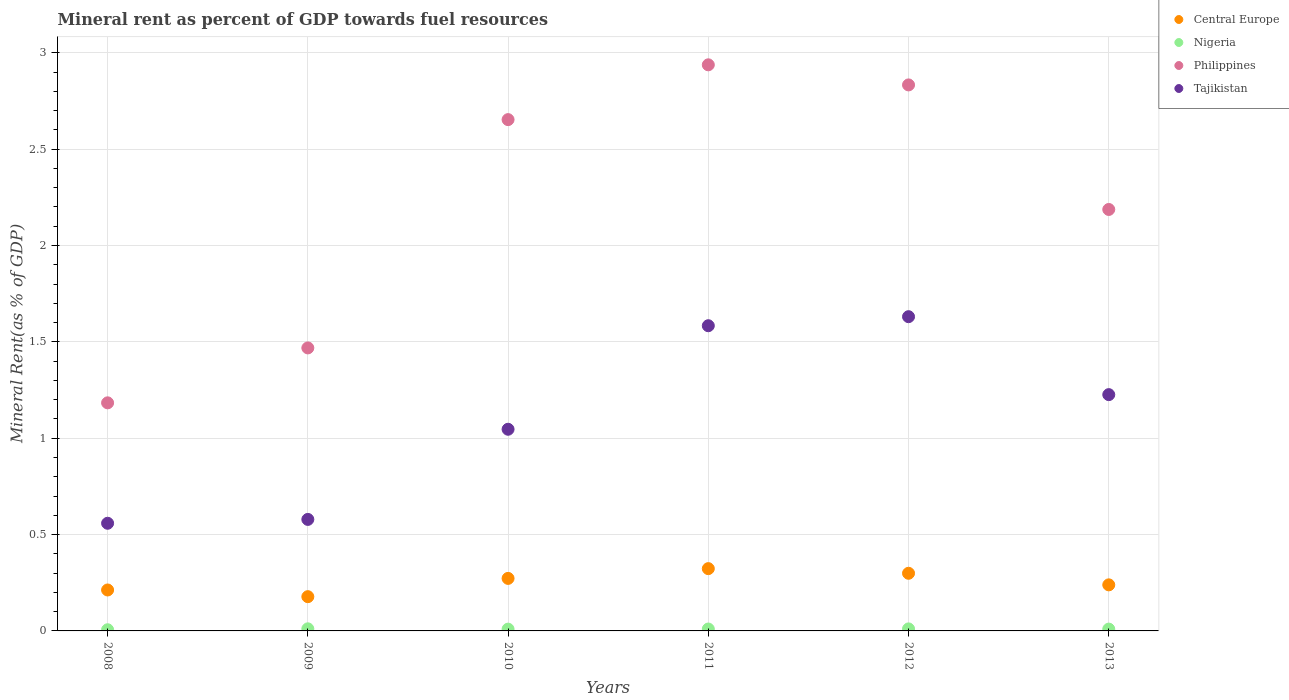How many different coloured dotlines are there?
Provide a short and direct response. 4. Is the number of dotlines equal to the number of legend labels?
Your response must be concise. Yes. What is the mineral rent in Nigeria in 2011?
Give a very brief answer. 0.01. Across all years, what is the maximum mineral rent in Tajikistan?
Provide a succinct answer. 1.63. Across all years, what is the minimum mineral rent in Philippines?
Make the answer very short. 1.18. What is the total mineral rent in Philippines in the graph?
Give a very brief answer. 13.26. What is the difference between the mineral rent in Central Europe in 2009 and that in 2012?
Provide a short and direct response. -0.12. What is the difference between the mineral rent in Central Europe in 2011 and the mineral rent in Tajikistan in 2010?
Your answer should be very brief. -0.72. What is the average mineral rent in Tajikistan per year?
Your response must be concise. 1.1. In the year 2010, what is the difference between the mineral rent in Nigeria and mineral rent in Tajikistan?
Make the answer very short. -1.04. In how many years, is the mineral rent in Philippines greater than 1.9 %?
Make the answer very short. 4. What is the ratio of the mineral rent in Philippines in 2009 to that in 2013?
Keep it short and to the point. 0.67. Is the mineral rent in Philippines in 2009 less than that in 2012?
Offer a terse response. Yes. What is the difference between the highest and the second highest mineral rent in Tajikistan?
Ensure brevity in your answer.  0.05. What is the difference between the highest and the lowest mineral rent in Nigeria?
Keep it short and to the point. 0. In how many years, is the mineral rent in Philippines greater than the average mineral rent in Philippines taken over all years?
Provide a succinct answer. 3. Is it the case that in every year, the sum of the mineral rent in Tajikistan and mineral rent in Philippines  is greater than the mineral rent in Central Europe?
Give a very brief answer. Yes. Does the mineral rent in Philippines monotonically increase over the years?
Provide a succinct answer. No. Is the mineral rent in Nigeria strictly greater than the mineral rent in Central Europe over the years?
Provide a succinct answer. No. How many dotlines are there?
Make the answer very short. 4. What is the difference between two consecutive major ticks on the Y-axis?
Keep it short and to the point. 0.5. Does the graph contain any zero values?
Provide a succinct answer. No. Does the graph contain grids?
Provide a succinct answer. Yes. How are the legend labels stacked?
Ensure brevity in your answer.  Vertical. What is the title of the graph?
Make the answer very short. Mineral rent as percent of GDP towards fuel resources. Does "Low & middle income" appear as one of the legend labels in the graph?
Offer a very short reply. No. What is the label or title of the X-axis?
Ensure brevity in your answer.  Years. What is the label or title of the Y-axis?
Offer a terse response. Mineral Rent(as % of GDP). What is the Mineral Rent(as % of GDP) in Central Europe in 2008?
Offer a terse response. 0.21. What is the Mineral Rent(as % of GDP) in Nigeria in 2008?
Ensure brevity in your answer.  0.01. What is the Mineral Rent(as % of GDP) of Philippines in 2008?
Your answer should be compact. 1.18. What is the Mineral Rent(as % of GDP) in Tajikistan in 2008?
Make the answer very short. 0.56. What is the Mineral Rent(as % of GDP) of Central Europe in 2009?
Provide a short and direct response. 0.18. What is the Mineral Rent(as % of GDP) in Nigeria in 2009?
Your answer should be very brief. 0.01. What is the Mineral Rent(as % of GDP) in Philippines in 2009?
Your answer should be compact. 1.47. What is the Mineral Rent(as % of GDP) in Tajikistan in 2009?
Your answer should be compact. 0.58. What is the Mineral Rent(as % of GDP) of Central Europe in 2010?
Offer a terse response. 0.27. What is the Mineral Rent(as % of GDP) of Nigeria in 2010?
Provide a succinct answer. 0.01. What is the Mineral Rent(as % of GDP) of Philippines in 2010?
Give a very brief answer. 2.65. What is the Mineral Rent(as % of GDP) in Tajikistan in 2010?
Your response must be concise. 1.05. What is the Mineral Rent(as % of GDP) in Central Europe in 2011?
Offer a terse response. 0.32. What is the Mineral Rent(as % of GDP) of Nigeria in 2011?
Your response must be concise. 0.01. What is the Mineral Rent(as % of GDP) of Philippines in 2011?
Provide a short and direct response. 2.94. What is the Mineral Rent(as % of GDP) in Tajikistan in 2011?
Your answer should be very brief. 1.58. What is the Mineral Rent(as % of GDP) in Central Europe in 2012?
Keep it short and to the point. 0.3. What is the Mineral Rent(as % of GDP) of Nigeria in 2012?
Provide a succinct answer. 0.01. What is the Mineral Rent(as % of GDP) in Philippines in 2012?
Offer a very short reply. 2.83. What is the Mineral Rent(as % of GDP) in Tajikistan in 2012?
Your answer should be compact. 1.63. What is the Mineral Rent(as % of GDP) of Central Europe in 2013?
Provide a short and direct response. 0.24. What is the Mineral Rent(as % of GDP) of Nigeria in 2013?
Give a very brief answer. 0.01. What is the Mineral Rent(as % of GDP) in Philippines in 2013?
Offer a terse response. 2.19. What is the Mineral Rent(as % of GDP) of Tajikistan in 2013?
Ensure brevity in your answer.  1.23. Across all years, what is the maximum Mineral Rent(as % of GDP) in Central Europe?
Your answer should be compact. 0.32. Across all years, what is the maximum Mineral Rent(as % of GDP) in Nigeria?
Keep it short and to the point. 0.01. Across all years, what is the maximum Mineral Rent(as % of GDP) in Philippines?
Your answer should be very brief. 2.94. Across all years, what is the maximum Mineral Rent(as % of GDP) of Tajikistan?
Make the answer very short. 1.63. Across all years, what is the minimum Mineral Rent(as % of GDP) of Central Europe?
Ensure brevity in your answer.  0.18. Across all years, what is the minimum Mineral Rent(as % of GDP) in Nigeria?
Your answer should be very brief. 0.01. Across all years, what is the minimum Mineral Rent(as % of GDP) in Philippines?
Offer a very short reply. 1.18. Across all years, what is the minimum Mineral Rent(as % of GDP) of Tajikistan?
Provide a short and direct response. 0.56. What is the total Mineral Rent(as % of GDP) of Central Europe in the graph?
Offer a terse response. 1.52. What is the total Mineral Rent(as % of GDP) in Nigeria in the graph?
Provide a succinct answer. 0.06. What is the total Mineral Rent(as % of GDP) of Philippines in the graph?
Your answer should be very brief. 13.26. What is the total Mineral Rent(as % of GDP) of Tajikistan in the graph?
Provide a succinct answer. 6.62. What is the difference between the Mineral Rent(as % of GDP) of Central Europe in 2008 and that in 2009?
Provide a succinct answer. 0.03. What is the difference between the Mineral Rent(as % of GDP) in Nigeria in 2008 and that in 2009?
Ensure brevity in your answer.  -0. What is the difference between the Mineral Rent(as % of GDP) in Philippines in 2008 and that in 2009?
Your answer should be very brief. -0.28. What is the difference between the Mineral Rent(as % of GDP) of Tajikistan in 2008 and that in 2009?
Make the answer very short. -0.02. What is the difference between the Mineral Rent(as % of GDP) of Central Europe in 2008 and that in 2010?
Ensure brevity in your answer.  -0.06. What is the difference between the Mineral Rent(as % of GDP) in Nigeria in 2008 and that in 2010?
Make the answer very short. -0. What is the difference between the Mineral Rent(as % of GDP) in Philippines in 2008 and that in 2010?
Ensure brevity in your answer.  -1.47. What is the difference between the Mineral Rent(as % of GDP) in Tajikistan in 2008 and that in 2010?
Your answer should be compact. -0.49. What is the difference between the Mineral Rent(as % of GDP) in Central Europe in 2008 and that in 2011?
Your answer should be very brief. -0.11. What is the difference between the Mineral Rent(as % of GDP) in Nigeria in 2008 and that in 2011?
Your answer should be compact. -0. What is the difference between the Mineral Rent(as % of GDP) in Philippines in 2008 and that in 2011?
Keep it short and to the point. -1.75. What is the difference between the Mineral Rent(as % of GDP) of Tajikistan in 2008 and that in 2011?
Your response must be concise. -1.03. What is the difference between the Mineral Rent(as % of GDP) in Central Europe in 2008 and that in 2012?
Provide a short and direct response. -0.09. What is the difference between the Mineral Rent(as % of GDP) of Nigeria in 2008 and that in 2012?
Offer a very short reply. -0. What is the difference between the Mineral Rent(as % of GDP) in Philippines in 2008 and that in 2012?
Provide a succinct answer. -1.65. What is the difference between the Mineral Rent(as % of GDP) in Tajikistan in 2008 and that in 2012?
Provide a succinct answer. -1.07. What is the difference between the Mineral Rent(as % of GDP) in Central Europe in 2008 and that in 2013?
Provide a succinct answer. -0.03. What is the difference between the Mineral Rent(as % of GDP) in Nigeria in 2008 and that in 2013?
Your answer should be compact. -0. What is the difference between the Mineral Rent(as % of GDP) in Philippines in 2008 and that in 2013?
Offer a very short reply. -1. What is the difference between the Mineral Rent(as % of GDP) of Tajikistan in 2008 and that in 2013?
Your answer should be very brief. -0.67. What is the difference between the Mineral Rent(as % of GDP) of Central Europe in 2009 and that in 2010?
Ensure brevity in your answer.  -0.09. What is the difference between the Mineral Rent(as % of GDP) of Nigeria in 2009 and that in 2010?
Ensure brevity in your answer.  0. What is the difference between the Mineral Rent(as % of GDP) in Philippines in 2009 and that in 2010?
Provide a succinct answer. -1.18. What is the difference between the Mineral Rent(as % of GDP) of Tajikistan in 2009 and that in 2010?
Provide a short and direct response. -0.47. What is the difference between the Mineral Rent(as % of GDP) of Central Europe in 2009 and that in 2011?
Keep it short and to the point. -0.15. What is the difference between the Mineral Rent(as % of GDP) in Philippines in 2009 and that in 2011?
Your response must be concise. -1.47. What is the difference between the Mineral Rent(as % of GDP) of Tajikistan in 2009 and that in 2011?
Offer a very short reply. -1.01. What is the difference between the Mineral Rent(as % of GDP) of Central Europe in 2009 and that in 2012?
Give a very brief answer. -0.12. What is the difference between the Mineral Rent(as % of GDP) in Philippines in 2009 and that in 2012?
Offer a terse response. -1.36. What is the difference between the Mineral Rent(as % of GDP) of Tajikistan in 2009 and that in 2012?
Give a very brief answer. -1.05. What is the difference between the Mineral Rent(as % of GDP) in Central Europe in 2009 and that in 2013?
Offer a terse response. -0.06. What is the difference between the Mineral Rent(as % of GDP) in Nigeria in 2009 and that in 2013?
Your answer should be compact. 0. What is the difference between the Mineral Rent(as % of GDP) of Philippines in 2009 and that in 2013?
Your answer should be compact. -0.72. What is the difference between the Mineral Rent(as % of GDP) in Tajikistan in 2009 and that in 2013?
Offer a terse response. -0.65. What is the difference between the Mineral Rent(as % of GDP) in Central Europe in 2010 and that in 2011?
Your answer should be very brief. -0.05. What is the difference between the Mineral Rent(as % of GDP) in Nigeria in 2010 and that in 2011?
Keep it short and to the point. -0. What is the difference between the Mineral Rent(as % of GDP) of Philippines in 2010 and that in 2011?
Offer a very short reply. -0.28. What is the difference between the Mineral Rent(as % of GDP) of Tajikistan in 2010 and that in 2011?
Provide a succinct answer. -0.54. What is the difference between the Mineral Rent(as % of GDP) of Central Europe in 2010 and that in 2012?
Offer a terse response. -0.03. What is the difference between the Mineral Rent(as % of GDP) in Nigeria in 2010 and that in 2012?
Your response must be concise. -0. What is the difference between the Mineral Rent(as % of GDP) in Philippines in 2010 and that in 2012?
Your response must be concise. -0.18. What is the difference between the Mineral Rent(as % of GDP) of Tajikistan in 2010 and that in 2012?
Your answer should be compact. -0.58. What is the difference between the Mineral Rent(as % of GDP) of Central Europe in 2010 and that in 2013?
Ensure brevity in your answer.  0.03. What is the difference between the Mineral Rent(as % of GDP) of Nigeria in 2010 and that in 2013?
Give a very brief answer. -0. What is the difference between the Mineral Rent(as % of GDP) of Philippines in 2010 and that in 2013?
Your answer should be very brief. 0.47. What is the difference between the Mineral Rent(as % of GDP) of Tajikistan in 2010 and that in 2013?
Your answer should be very brief. -0.18. What is the difference between the Mineral Rent(as % of GDP) of Central Europe in 2011 and that in 2012?
Keep it short and to the point. 0.02. What is the difference between the Mineral Rent(as % of GDP) of Nigeria in 2011 and that in 2012?
Provide a short and direct response. -0. What is the difference between the Mineral Rent(as % of GDP) of Philippines in 2011 and that in 2012?
Your answer should be compact. 0.1. What is the difference between the Mineral Rent(as % of GDP) of Tajikistan in 2011 and that in 2012?
Keep it short and to the point. -0.05. What is the difference between the Mineral Rent(as % of GDP) in Central Europe in 2011 and that in 2013?
Your response must be concise. 0.08. What is the difference between the Mineral Rent(as % of GDP) of Philippines in 2011 and that in 2013?
Provide a short and direct response. 0.75. What is the difference between the Mineral Rent(as % of GDP) of Tajikistan in 2011 and that in 2013?
Ensure brevity in your answer.  0.36. What is the difference between the Mineral Rent(as % of GDP) in Central Europe in 2012 and that in 2013?
Provide a succinct answer. 0.06. What is the difference between the Mineral Rent(as % of GDP) in Nigeria in 2012 and that in 2013?
Offer a terse response. 0. What is the difference between the Mineral Rent(as % of GDP) in Philippines in 2012 and that in 2013?
Your response must be concise. 0.65. What is the difference between the Mineral Rent(as % of GDP) in Tajikistan in 2012 and that in 2013?
Your answer should be compact. 0.4. What is the difference between the Mineral Rent(as % of GDP) of Central Europe in 2008 and the Mineral Rent(as % of GDP) of Nigeria in 2009?
Your response must be concise. 0.2. What is the difference between the Mineral Rent(as % of GDP) in Central Europe in 2008 and the Mineral Rent(as % of GDP) in Philippines in 2009?
Your response must be concise. -1.26. What is the difference between the Mineral Rent(as % of GDP) in Central Europe in 2008 and the Mineral Rent(as % of GDP) in Tajikistan in 2009?
Offer a terse response. -0.37. What is the difference between the Mineral Rent(as % of GDP) of Nigeria in 2008 and the Mineral Rent(as % of GDP) of Philippines in 2009?
Your response must be concise. -1.46. What is the difference between the Mineral Rent(as % of GDP) of Nigeria in 2008 and the Mineral Rent(as % of GDP) of Tajikistan in 2009?
Provide a short and direct response. -0.57. What is the difference between the Mineral Rent(as % of GDP) of Philippines in 2008 and the Mineral Rent(as % of GDP) of Tajikistan in 2009?
Ensure brevity in your answer.  0.6. What is the difference between the Mineral Rent(as % of GDP) in Central Europe in 2008 and the Mineral Rent(as % of GDP) in Nigeria in 2010?
Your response must be concise. 0.2. What is the difference between the Mineral Rent(as % of GDP) of Central Europe in 2008 and the Mineral Rent(as % of GDP) of Philippines in 2010?
Give a very brief answer. -2.44. What is the difference between the Mineral Rent(as % of GDP) of Central Europe in 2008 and the Mineral Rent(as % of GDP) of Tajikistan in 2010?
Your answer should be very brief. -0.83. What is the difference between the Mineral Rent(as % of GDP) of Nigeria in 2008 and the Mineral Rent(as % of GDP) of Philippines in 2010?
Provide a succinct answer. -2.65. What is the difference between the Mineral Rent(as % of GDP) in Nigeria in 2008 and the Mineral Rent(as % of GDP) in Tajikistan in 2010?
Offer a very short reply. -1.04. What is the difference between the Mineral Rent(as % of GDP) in Philippines in 2008 and the Mineral Rent(as % of GDP) in Tajikistan in 2010?
Provide a succinct answer. 0.14. What is the difference between the Mineral Rent(as % of GDP) in Central Europe in 2008 and the Mineral Rent(as % of GDP) in Nigeria in 2011?
Provide a succinct answer. 0.2. What is the difference between the Mineral Rent(as % of GDP) of Central Europe in 2008 and the Mineral Rent(as % of GDP) of Philippines in 2011?
Your answer should be very brief. -2.73. What is the difference between the Mineral Rent(as % of GDP) in Central Europe in 2008 and the Mineral Rent(as % of GDP) in Tajikistan in 2011?
Offer a terse response. -1.37. What is the difference between the Mineral Rent(as % of GDP) in Nigeria in 2008 and the Mineral Rent(as % of GDP) in Philippines in 2011?
Keep it short and to the point. -2.93. What is the difference between the Mineral Rent(as % of GDP) in Nigeria in 2008 and the Mineral Rent(as % of GDP) in Tajikistan in 2011?
Ensure brevity in your answer.  -1.58. What is the difference between the Mineral Rent(as % of GDP) of Philippines in 2008 and the Mineral Rent(as % of GDP) of Tajikistan in 2011?
Keep it short and to the point. -0.4. What is the difference between the Mineral Rent(as % of GDP) of Central Europe in 2008 and the Mineral Rent(as % of GDP) of Nigeria in 2012?
Your answer should be compact. 0.2. What is the difference between the Mineral Rent(as % of GDP) in Central Europe in 2008 and the Mineral Rent(as % of GDP) in Philippines in 2012?
Make the answer very short. -2.62. What is the difference between the Mineral Rent(as % of GDP) of Central Europe in 2008 and the Mineral Rent(as % of GDP) of Tajikistan in 2012?
Your answer should be compact. -1.42. What is the difference between the Mineral Rent(as % of GDP) of Nigeria in 2008 and the Mineral Rent(as % of GDP) of Philippines in 2012?
Your answer should be compact. -2.83. What is the difference between the Mineral Rent(as % of GDP) in Nigeria in 2008 and the Mineral Rent(as % of GDP) in Tajikistan in 2012?
Ensure brevity in your answer.  -1.62. What is the difference between the Mineral Rent(as % of GDP) of Philippines in 2008 and the Mineral Rent(as % of GDP) of Tajikistan in 2012?
Provide a short and direct response. -0.45. What is the difference between the Mineral Rent(as % of GDP) in Central Europe in 2008 and the Mineral Rent(as % of GDP) in Nigeria in 2013?
Your answer should be very brief. 0.2. What is the difference between the Mineral Rent(as % of GDP) in Central Europe in 2008 and the Mineral Rent(as % of GDP) in Philippines in 2013?
Provide a succinct answer. -1.97. What is the difference between the Mineral Rent(as % of GDP) in Central Europe in 2008 and the Mineral Rent(as % of GDP) in Tajikistan in 2013?
Make the answer very short. -1.01. What is the difference between the Mineral Rent(as % of GDP) in Nigeria in 2008 and the Mineral Rent(as % of GDP) in Philippines in 2013?
Ensure brevity in your answer.  -2.18. What is the difference between the Mineral Rent(as % of GDP) in Nigeria in 2008 and the Mineral Rent(as % of GDP) in Tajikistan in 2013?
Provide a short and direct response. -1.22. What is the difference between the Mineral Rent(as % of GDP) in Philippines in 2008 and the Mineral Rent(as % of GDP) in Tajikistan in 2013?
Make the answer very short. -0.04. What is the difference between the Mineral Rent(as % of GDP) of Central Europe in 2009 and the Mineral Rent(as % of GDP) of Nigeria in 2010?
Give a very brief answer. 0.17. What is the difference between the Mineral Rent(as % of GDP) in Central Europe in 2009 and the Mineral Rent(as % of GDP) in Philippines in 2010?
Provide a short and direct response. -2.48. What is the difference between the Mineral Rent(as % of GDP) in Central Europe in 2009 and the Mineral Rent(as % of GDP) in Tajikistan in 2010?
Your answer should be compact. -0.87. What is the difference between the Mineral Rent(as % of GDP) in Nigeria in 2009 and the Mineral Rent(as % of GDP) in Philippines in 2010?
Ensure brevity in your answer.  -2.64. What is the difference between the Mineral Rent(as % of GDP) in Nigeria in 2009 and the Mineral Rent(as % of GDP) in Tajikistan in 2010?
Offer a terse response. -1.04. What is the difference between the Mineral Rent(as % of GDP) of Philippines in 2009 and the Mineral Rent(as % of GDP) of Tajikistan in 2010?
Your answer should be compact. 0.42. What is the difference between the Mineral Rent(as % of GDP) of Central Europe in 2009 and the Mineral Rent(as % of GDP) of Nigeria in 2011?
Ensure brevity in your answer.  0.17. What is the difference between the Mineral Rent(as % of GDP) of Central Europe in 2009 and the Mineral Rent(as % of GDP) of Philippines in 2011?
Provide a succinct answer. -2.76. What is the difference between the Mineral Rent(as % of GDP) in Central Europe in 2009 and the Mineral Rent(as % of GDP) in Tajikistan in 2011?
Your answer should be compact. -1.41. What is the difference between the Mineral Rent(as % of GDP) in Nigeria in 2009 and the Mineral Rent(as % of GDP) in Philippines in 2011?
Make the answer very short. -2.93. What is the difference between the Mineral Rent(as % of GDP) in Nigeria in 2009 and the Mineral Rent(as % of GDP) in Tajikistan in 2011?
Offer a terse response. -1.57. What is the difference between the Mineral Rent(as % of GDP) in Philippines in 2009 and the Mineral Rent(as % of GDP) in Tajikistan in 2011?
Keep it short and to the point. -0.12. What is the difference between the Mineral Rent(as % of GDP) in Central Europe in 2009 and the Mineral Rent(as % of GDP) in Nigeria in 2012?
Ensure brevity in your answer.  0.17. What is the difference between the Mineral Rent(as % of GDP) in Central Europe in 2009 and the Mineral Rent(as % of GDP) in Philippines in 2012?
Offer a terse response. -2.66. What is the difference between the Mineral Rent(as % of GDP) in Central Europe in 2009 and the Mineral Rent(as % of GDP) in Tajikistan in 2012?
Provide a short and direct response. -1.45. What is the difference between the Mineral Rent(as % of GDP) of Nigeria in 2009 and the Mineral Rent(as % of GDP) of Philippines in 2012?
Ensure brevity in your answer.  -2.82. What is the difference between the Mineral Rent(as % of GDP) in Nigeria in 2009 and the Mineral Rent(as % of GDP) in Tajikistan in 2012?
Your answer should be compact. -1.62. What is the difference between the Mineral Rent(as % of GDP) in Philippines in 2009 and the Mineral Rent(as % of GDP) in Tajikistan in 2012?
Ensure brevity in your answer.  -0.16. What is the difference between the Mineral Rent(as % of GDP) of Central Europe in 2009 and the Mineral Rent(as % of GDP) of Nigeria in 2013?
Keep it short and to the point. 0.17. What is the difference between the Mineral Rent(as % of GDP) in Central Europe in 2009 and the Mineral Rent(as % of GDP) in Philippines in 2013?
Keep it short and to the point. -2.01. What is the difference between the Mineral Rent(as % of GDP) in Central Europe in 2009 and the Mineral Rent(as % of GDP) in Tajikistan in 2013?
Make the answer very short. -1.05. What is the difference between the Mineral Rent(as % of GDP) of Nigeria in 2009 and the Mineral Rent(as % of GDP) of Philippines in 2013?
Make the answer very short. -2.18. What is the difference between the Mineral Rent(as % of GDP) of Nigeria in 2009 and the Mineral Rent(as % of GDP) of Tajikistan in 2013?
Ensure brevity in your answer.  -1.22. What is the difference between the Mineral Rent(as % of GDP) in Philippines in 2009 and the Mineral Rent(as % of GDP) in Tajikistan in 2013?
Offer a terse response. 0.24. What is the difference between the Mineral Rent(as % of GDP) of Central Europe in 2010 and the Mineral Rent(as % of GDP) of Nigeria in 2011?
Provide a short and direct response. 0.26. What is the difference between the Mineral Rent(as % of GDP) in Central Europe in 2010 and the Mineral Rent(as % of GDP) in Philippines in 2011?
Your answer should be compact. -2.67. What is the difference between the Mineral Rent(as % of GDP) of Central Europe in 2010 and the Mineral Rent(as % of GDP) of Tajikistan in 2011?
Offer a terse response. -1.31. What is the difference between the Mineral Rent(as % of GDP) of Nigeria in 2010 and the Mineral Rent(as % of GDP) of Philippines in 2011?
Your answer should be very brief. -2.93. What is the difference between the Mineral Rent(as % of GDP) in Nigeria in 2010 and the Mineral Rent(as % of GDP) in Tajikistan in 2011?
Ensure brevity in your answer.  -1.57. What is the difference between the Mineral Rent(as % of GDP) of Philippines in 2010 and the Mineral Rent(as % of GDP) of Tajikistan in 2011?
Offer a terse response. 1.07. What is the difference between the Mineral Rent(as % of GDP) in Central Europe in 2010 and the Mineral Rent(as % of GDP) in Nigeria in 2012?
Your answer should be very brief. 0.26. What is the difference between the Mineral Rent(as % of GDP) of Central Europe in 2010 and the Mineral Rent(as % of GDP) of Philippines in 2012?
Your answer should be very brief. -2.56. What is the difference between the Mineral Rent(as % of GDP) of Central Europe in 2010 and the Mineral Rent(as % of GDP) of Tajikistan in 2012?
Give a very brief answer. -1.36. What is the difference between the Mineral Rent(as % of GDP) in Nigeria in 2010 and the Mineral Rent(as % of GDP) in Philippines in 2012?
Your response must be concise. -2.82. What is the difference between the Mineral Rent(as % of GDP) of Nigeria in 2010 and the Mineral Rent(as % of GDP) of Tajikistan in 2012?
Your answer should be compact. -1.62. What is the difference between the Mineral Rent(as % of GDP) in Philippines in 2010 and the Mineral Rent(as % of GDP) in Tajikistan in 2012?
Your answer should be compact. 1.02. What is the difference between the Mineral Rent(as % of GDP) of Central Europe in 2010 and the Mineral Rent(as % of GDP) of Nigeria in 2013?
Offer a terse response. 0.26. What is the difference between the Mineral Rent(as % of GDP) in Central Europe in 2010 and the Mineral Rent(as % of GDP) in Philippines in 2013?
Offer a very short reply. -1.91. What is the difference between the Mineral Rent(as % of GDP) of Central Europe in 2010 and the Mineral Rent(as % of GDP) of Tajikistan in 2013?
Your answer should be compact. -0.95. What is the difference between the Mineral Rent(as % of GDP) in Nigeria in 2010 and the Mineral Rent(as % of GDP) in Philippines in 2013?
Your answer should be very brief. -2.18. What is the difference between the Mineral Rent(as % of GDP) of Nigeria in 2010 and the Mineral Rent(as % of GDP) of Tajikistan in 2013?
Keep it short and to the point. -1.22. What is the difference between the Mineral Rent(as % of GDP) of Philippines in 2010 and the Mineral Rent(as % of GDP) of Tajikistan in 2013?
Provide a succinct answer. 1.43. What is the difference between the Mineral Rent(as % of GDP) of Central Europe in 2011 and the Mineral Rent(as % of GDP) of Nigeria in 2012?
Provide a short and direct response. 0.31. What is the difference between the Mineral Rent(as % of GDP) of Central Europe in 2011 and the Mineral Rent(as % of GDP) of Philippines in 2012?
Keep it short and to the point. -2.51. What is the difference between the Mineral Rent(as % of GDP) in Central Europe in 2011 and the Mineral Rent(as % of GDP) in Tajikistan in 2012?
Keep it short and to the point. -1.31. What is the difference between the Mineral Rent(as % of GDP) in Nigeria in 2011 and the Mineral Rent(as % of GDP) in Philippines in 2012?
Make the answer very short. -2.82. What is the difference between the Mineral Rent(as % of GDP) in Nigeria in 2011 and the Mineral Rent(as % of GDP) in Tajikistan in 2012?
Offer a very short reply. -1.62. What is the difference between the Mineral Rent(as % of GDP) in Philippines in 2011 and the Mineral Rent(as % of GDP) in Tajikistan in 2012?
Ensure brevity in your answer.  1.31. What is the difference between the Mineral Rent(as % of GDP) in Central Europe in 2011 and the Mineral Rent(as % of GDP) in Nigeria in 2013?
Keep it short and to the point. 0.31. What is the difference between the Mineral Rent(as % of GDP) of Central Europe in 2011 and the Mineral Rent(as % of GDP) of Philippines in 2013?
Provide a short and direct response. -1.86. What is the difference between the Mineral Rent(as % of GDP) of Central Europe in 2011 and the Mineral Rent(as % of GDP) of Tajikistan in 2013?
Your answer should be compact. -0.9. What is the difference between the Mineral Rent(as % of GDP) in Nigeria in 2011 and the Mineral Rent(as % of GDP) in Philippines in 2013?
Your answer should be very brief. -2.18. What is the difference between the Mineral Rent(as % of GDP) of Nigeria in 2011 and the Mineral Rent(as % of GDP) of Tajikistan in 2013?
Ensure brevity in your answer.  -1.22. What is the difference between the Mineral Rent(as % of GDP) in Philippines in 2011 and the Mineral Rent(as % of GDP) in Tajikistan in 2013?
Your answer should be compact. 1.71. What is the difference between the Mineral Rent(as % of GDP) of Central Europe in 2012 and the Mineral Rent(as % of GDP) of Nigeria in 2013?
Your answer should be compact. 0.29. What is the difference between the Mineral Rent(as % of GDP) in Central Europe in 2012 and the Mineral Rent(as % of GDP) in Philippines in 2013?
Give a very brief answer. -1.89. What is the difference between the Mineral Rent(as % of GDP) in Central Europe in 2012 and the Mineral Rent(as % of GDP) in Tajikistan in 2013?
Offer a terse response. -0.93. What is the difference between the Mineral Rent(as % of GDP) of Nigeria in 2012 and the Mineral Rent(as % of GDP) of Philippines in 2013?
Keep it short and to the point. -2.18. What is the difference between the Mineral Rent(as % of GDP) of Nigeria in 2012 and the Mineral Rent(as % of GDP) of Tajikistan in 2013?
Your response must be concise. -1.22. What is the difference between the Mineral Rent(as % of GDP) of Philippines in 2012 and the Mineral Rent(as % of GDP) of Tajikistan in 2013?
Keep it short and to the point. 1.61. What is the average Mineral Rent(as % of GDP) in Central Europe per year?
Offer a very short reply. 0.25. What is the average Mineral Rent(as % of GDP) of Nigeria per year?
Offer a very short reply. 0.01. What is the average Mineral Rent(as % of GDP) of Philippines per year?
Ensure brevity in your answer.  2.21. What is the average Mineral Rent(as % of GDP) of Tajikistan per year?
Provide a succinct answer. 1.1. In the year 2008, what is the difference between the Mineral Rent(as % of GDP) of Central Europe and Mineral Rent(as % of GDP) of Nigeria?
Keep it short and to the point. 0.21. In the year 2008, what is the difference between the Mineral Rent(as % of GDP) of Central Europe and Mineral Rent(as % of GDP) of Philippines?
Ensure brevity in your answer.  -0.97. In the year 2008, what is the difference between the Mineral Rent(as % of GDP) in Central Europe and Mineral Rent(as % of GDP) in Tajikistan?
Your answer should be very brief. -0.35. In the year 2008, what is the difference between the Mineral Rent(as % of GDP) in Nigeria and Mineral Rent(as % of GDP) in Philippines?
Your answer should be very brief. -1.18. In the year 2008, what is the difference between the Mineral Rent(as % of GDP) of Nigeria and Mineral Rent(as % of GDP) of Tajikistan?
Your response must be concise. -0.55. In the year 2008, what is the difference between the Mineral Rent(as % of GDP) in Philippines and Mineral Rent(as % of GDP) in Tajikistan?
Provide a succinct answer. 0.62. In the year 2009, what is the difference between the Mineral Rent(as % of GDP) in Central Europe and Mineral Rent(as % of GDP) in Nigeria?
Provide a short and direct response. 0.17. In the year 2009, what is the difference between the Mineral Rent(as % of GDP) in Central Europe and Mineral Rent(as % of GDP) in Philippines?
Your answer should be compact. -1.29. In the year 2009, what is the difference between the Mineral Rent(as % of GDP) in Central Europe and Mineral Rent(as % of GDP) in Tajikistan?
Offer a terse response. -0.4. In the year 2009, what is the difference between the Mineral Rent(as % of GDP) of Nigeria and Mineral Rent(as % of GDP) of Philippines?
Your answer should be compact. -1.46. In the year 2009, what is the difference between the Mineral Rent(as % of GDP) of Nigeria and Mineral Rent(as % of GDP) of Tajikistan?
Provide a succinct answer. -0.57. In the year 2009, what is the difference between the Mineral Rent(as % of GDP) in Philippines and Mineral Rent(as % of GDP) in Tajikistan?
Your response must be concise. 0.89. In the year 2010, what is the difference between the Mineral Rent(as % of GDP) in Central Europe and Mineral Rent(as % of GDP) in Nigeria?
Keep it short and to the point. 0.26. In the year 2010, what is the difference between the Mineral Rent(as % of GDP) in Central Europe and Mineral Rent(as % of GDP) in Philippines?
Offer a very short reply. -2.38. In the year 2010, what is the difference between the Mineral Rent(as % of GDP) in Central Europe and Mineral Rent(as % of GDP) in Tajikistan?
Make the answer very short. -0.77. In the year 2010, what is the difference between the Mineral Rent(as % of GDP) of Nigeria and Mineral Rent(as % of GDP) of Philippines?
Make the answer very short. -2.64. In the year 2010, what is the difference between the Mineral Rent(as % of GDP) of Nigeria and Mineral Rent(as % of GDP) of Tajikistan?
Offer a very short reply. -1.04. In the year 2010, what is the difference between the Mineral Rent(as % of GDP) of Philippines and Mineral Rent(as % of GDP) of Tajikistan?
Offer a very short reply. 1.61. In the year 2011, what is the difference between the Mineral Rent(as % of GDP) in Central Europe and Mineral Rent(as % of GDP) in Nigeria?
Offer a terse response. 0.31. In the year 2011, what is the difference between the Mineral Rent(as % of GDP) of Central Europe and Mineral Rent(as % of GDP) of Philippines?
Your response must be concise. -2.61. In the year 2011, what is the difference between the Mineral Rent(as % of GDP) of Central Europe and Mineral Rent(as % of GDP) of Tajikistan?
Ensure brevity in your answer.  -1.26. In the year 2011, what is the difference between the Mineral Rent(as % of GDP) of Nigeria and Mineral Rent(as % of GDP) of Philippines?
Offer a terse response. -2.93. In the year 2011, what is the difference between the Mineral Rent(as % of GDP) in Nigeria and Mineral Rent(as % of GDP) in Tajikistan?
Your answer should be very brief. -1.57. In the year 2011, what is the difference between the Mineral Rent(as % of GDP) in Philippines and Mineral Rent(as % of GDP) in Tajikistan?
Give a very brief answer. 1.35. In the year 2012, what is the difference between the Mineral Rent(as % of GDP) of Central Europe and Mineral Rent(as % of GDP) of Nigeria?
Keep it short and to the point. 0.29. In the year 2012, what is the difference between the Mineral Rent(as % of GDP) in Central Europe and Mineral Rent(as % of GDP) in Philippines?
Give a very brief answer. -2.53. In the year 2012, what is the difference between the Mineral Rent(as % of GDP) in Central Europe and Mineral Rent(as % of GDP) in Tajikistan?
Keep it short and to the point. -1.33. In the year 2012, what is the difference between the Mineral Rent(as % of GDP) in Nigeria and Mineral Rent(as % of GDP) in Philippines?
Provide a succinct answer. -2.82. In the year 2012, what is the difference between the Mineral Rent(as % of GDP) in Nigeria and Mineral Rent(as % of GDP) in Tajikistan?
Ensure brevity in your answer.  -1.62. In the year 2012, what is the difference between the Mineral Rent(as % of GDP) in Philippines and Mineral Rent(as % of GDP) in Tajikistan?
Offer a terse response. 1.2. In the year 2013, what is the difference between the Mineral Rent(as % of GDP) of Central Europe and Mineral Rent(as % of GDP) of Nigeria?
Give a very brief answer. 0.23. In the year 2013, what is the difference between the Mineral Rent(as % of GDP) in Central Europe and Mineral Rent(as % of GDP) in Philippines?
Your response must be concise. -1.95. In the year 2013, what is the difference between the Mineral Rent(as % of GDP) of Central Europe and Mineral Rent(as % of GDP) of Tajikistan?
Your response must be concise. -0.99. In the year 2013, what is the difference between the Mineral Rent(as % of GDP) of Nigeria and Mineral Rent(as % of GDP) of Philippines?
Your answer should be very brief. -2.18. In the year 2013, what is the difference between the Mineral Rent(as % of GDP) in Nigeria and Mineral Rent(as % of GDP) in Tajikistan?
Ensure brevity in your answer.  -1.22. In the year 2013, what is the difference between the Mineral Rent(as % of GDP) in Philippines and Mineral Rent(as % of GDP) in Tajikistan?
Your answer should be very brief. 0.96. What is the ratio of the Mineral Rent(as % of GDP) in Central Europe in 2008 to that in 2009?
Offer a very short reply. 1.2. What is the ratio of the Mineral Rent(as % of GDP) in Nigeria in 2008 to that in 2009?
Provide a succinct answer. 0.56. What is the ratio of the Mineral Rent(as % of GDP) of Philippines in 2008 to that in 2009?
Provide a short and direct response. 0.81. What is the ratio of the Mineral Rent(as % of GDP) in Tajikistan in 2008 to that in 2009?
Your answer should be very brief. 0.97. What is the ratio of the Mineral Rent(as % of GDP) of Central Europe in 2008 to that in 2010?
Your answer should be very brief. 0.78. What is the ratio of the Mineral Rent(as % of GDP) in Nigeria in 2008 to that in 2010?
Provide a succinct answer. 0.65. What is the ratio of the Mineral Rent(as % of GDP) of Philippines in 2008 to that in 2010?
Ensure brevity in your answer.  0.45. What is the ratio of the Mineral Rent(as % of GDP) of Tajikistan in 2008 to that in 2010?
Make the answer very short. 0.53. What is the ratio of the Mineral Rent(as % of GDP) in Central Europe in 2008 to that in 2011?
Ensure brevity in your answer.  0.66. What is the ratio of the Mineral Rent(as % of GDP) in Nigeria in 2008 to that in 2011?
Provide a short and direct response. 0.61. What is the ratio of the Mineral Rent(as % of GDP) of Philippines in 2008 to that in 2011?
Ensure brevity in your answer.  0.4. What is the ratio of the Mineral Rent(as % of GDP) in Tajikistan in 2008 to that in 2011?
Offer a terse response. 0.35. What is the ratio of the Mineral Rent(as % of GDP) in Central Europe in 2008 to that in 2012?
Your answer should be compact. 0.71. What is the ratio of the Mineral Rent(as % of GDP) of Nigeria in 2008 to that in 2012?
Offer a very short reply. 0.58. What is the ratio of the Mineral Rent(as % of GDP) in Philippines in 2008 to that in 2012?
Keep it short and to the point. 0.42. What is the ratio of the Mineral Rent(as % of GDP) of Tajikistan in 2008 to that in 2012?
Your response must be concise. 0.34. What is the ratio of the Mineral Rent(as % of GDP) of Central Europe in 2008 to that in 2013?
Ensure brevity in your answer.  0.89. What is the ratio of the Mineral Rent(as % of GDP) of Nigeria in 2008 to that in 2013?
Make the answer very short. 0.64. What is the ratio of the Mineral Rent(as % of GDP) of Philippines in 2008 to that in 2013?
Ensure brevity in your answer.  0.54. What is the ratio of the Mineral Rent(as % of GDP) of Tajikistan in 2008 to that in 2013?
Keep it short and to the point. 0.46. What is the ratio of the Mineral Rent(as % of GDP) of Central Europe in 2009 to that in 2010?
Your response must be concise. 0.65. What is the ratio of the Mineral Rent(as % of GDP) of Nigeria in 2009 to that in 2010?
Give a very brief answer. 1.17. What is the ratio of the Mineral Rent(as % of GDP) of Philippines in 2009 to that in 2010?
Give a very brief answer. 0.55. What is the ratio of the Mineral Rent(as % of GDP) in Tajikistan in 2009 to that in 2010?
Offer a terse response. 0.55. What is the ratio of the Mineral Rent(as % of GDP) of Central Europe in 2009 to that in 2011?
Ensure brevity in your answer.  0.55. What is the ratio of the Mineral Rent(as % of GDP) of Nigeria in 2009 to that in 2011?
Your answer should be compact. 1.1. What is the ratio of the Mineral Rent(as % of GDP) in Philippines in 2009 to that in 2011?
Offer a very short reply. 0.5. What is the ratio of the Mineral Rent(as % of GDP) in Tajikistan in 2009 to that in 2011?
Offer a terse response. 0.37. What is the ratio of the Mineral Rent(as % of GDP) of Central Europe in 2009 to that in 2012?
Keep it short and to the point. 0.59. What is the ratio of the Mineral Rent(as % of GDP) of Nigeria in 2009 to that in 2012?
Ensure brevity in your answer.  1.04. What is the ratio of the Mineral Rent(as % of GDP) in Philippines in 2009 to that in 2012?
Your answer should be very brief. 0.52. What is the ratio of the Mineral Rent(as % of GDP) of Tajikistan in 2009 to that in 2012?
Ensure brevity in your answer.  0.35. What is the ratio of the Mineral Rent(as % of GDP) of Central Europe in 2009 to that in 2013?
Your response must be concise. 0.74. What is the ratio of the Mineral Rent(as % of GDP) of Nigeria in 2009 to that in 2013?
Provide a short and direct response. 1.15. What is the ratio of the Mineral Rent(as % of GDP) of Philippines in 2009 to that in 2013?
Make the answer very short. 0.67. What is the ratio of the Mineral Rent(as % of GDP) in Tajikistan in 2009 to that in 2013?
Make the answer very short. 0.47. What is the ratio of the Mineral Rent(as % of GDP) in Central Europe in 2010 to that in 2011?
Give a very brief answer. 0.84. What is the ratio of the Mineral Rent(as % of GDP) in Nigeria in 2010 to that in 2011?
Ensure brevity in your answer.  0.94. What is the ratio of the Mineral Rent(as % of GDP) of Philippines in 2010 to that in 2011?
Give a very brief answer. 0.9. What is the ratio of the Mineral Rent(as % of GDP) of Tajikistan in 2010 to that in 2011?
Your answer should be compact. 0.66. What is the ratio of the Mineral Rent(as % of GDP) of Central Europe in 2010 to that in 2012?
Offer a very short reply. 0.91. What is the ratio of the Mineral Rent(as % of GDP) in Nigeria in 2010 to that in 2012?
Offer a very short reply. 0.89. What is the ratio of the Mineral Rent(as % of GDP) in Philippines in 2010 to that in 2012?
Make the answer very short. 0.94. What is the ratio of the Mineral Rent(as % of GDP) of Tajikistan in 2010 to that in 2012?
Keep it short and to the point. 0.64. What is the ratio of the Mineral Rent(as % of GDP) of Central Europe in 2010 to that in 2013?
Provide a short and direct response. 1.14. What is the ratio of the Mineral Rent(as % of GDP) in Nigeria in 2010 to that in 2013?
Give a very brief answer. 0.98. What is the ratio of the Mineral Rent(as % of GDP) of Philippines in 2010 to that in 2013?
Keep it short and to the point. 1.21. What is the ratio of the Mineral Rent(as % of GDP) of Tajikistan in 2010 to that in 2013?
Your response must be concise. 0.85. What is the ratio of the Mineral Rent(as % of GDP) in Central Europe in 2011 to that in 2012?
Your answer should be very brief. 1.08. What is the ratio of the Mineral Rent(as % of GDP) of Nigeria in 2011 to that in 2012?
Provide a short and direct response. 0.94. What is the ratio of the Mineral Rent(as % of GDP) in Philippines in 2011 to that in 2012?
Make the answer very short. 1.04. What is the ratio of the Mineral Rent(as % of GDP) in Tajikistan in 2011 to that in 2012?
Offer a terse response. 0.97. What is the ratio of the Mineral Rent(as % of GDP) of Central Europe in 2011 to that in 2013?
Your answer should be compact. 1.35. What is the ratio of the Mineral Rent(as % of GDP) in Nigeria in 2011 to that in 2013?
Keep it short and to the point. 1.04. What is the ratio of the Mineral Rent(as % of GDP) of Philippines in 2011 to that in 2013?
Provide a succinct answer. 1.34. What is the ratio of the Mineral Rent(as % of GDP) in Tajikistan in 2011 to that in 2013?
Your response must be concise. 1.29. What is the ratio of the Mineral Rent(as % of GDP) in Central Europe in 2012 to that in 2013?
Ensure brevity in your answer.  1.25. What is the ratio of the Mineral Rent(as % of GDP) in Nigeria in 2012 to that in 2013?
Your answer should be very brief. 1.11. What is the ratio of the Mineral Rent(as % of GDP) in Philippines in 2012 to that in 2013?
Make the answer very short. 1.3. What is the ratio of the Mineral Rent(as % of GDP) of Tajikistan in 2012 to that in 2013?
Keep it short and to the point. 1.33. What is the difference between the highest and the second highest Mineral Rent(as % of GDP) of Central Europe?
Make the answer very short. 0.02. What is the difference between the highest and the second highest Mineral Rent(as % of GDP) of Philippines?
Provide a short and direct response. 0.1. What is the difference between the highest and the second highest Mineral Rent(as % of GDP) of Tajikistan?
Your answer should be very brief. 0.05. What is the difference between the highest and the lowest Mineral Rent(as % of GDP) of Central Europe?
Provide a short and direct response. 0.15. What is the difference between the highest and the lowest Mineral Rent(as % of GDP) in Nigeria?
Your answer should be very brief. 0. What is the difference between the highest and the lowest Mineral Rent(as % of GDP) in Philippines?
Your answer should be very brief. 1.75. What is the difference between the highest and the lowest Mineral Rent(as % of GDP) in Tajikistan?
Offer a very short reply. 1.07. 